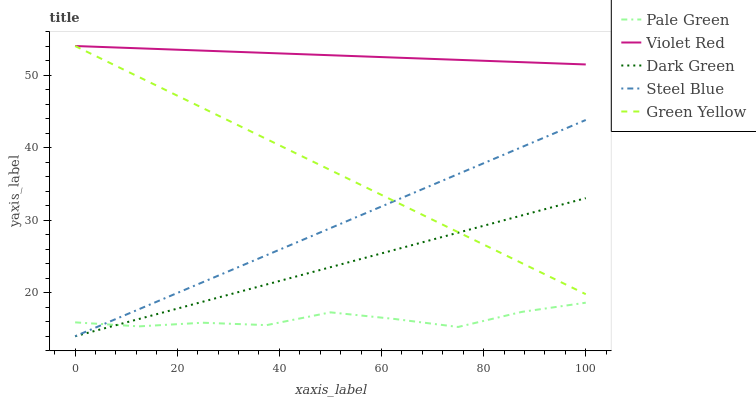Does Pale Green have the minimum area under the curve?
Answer yes or no. Yes. Does Violet Red have the maximum area under the curve?
Answer yes or no. Yes. Does Violet Red have the minimum area under the curve?
Answer yes or no. No. Does Pale Green have the maximum area under the curve?
Answer yes or no. No. Is Steel Blue the smoothest?
Answer yes or no. Yes. Is Pale Green the roughest?
Answer yes or no. Yes. Is Violet Red the smoothest?
Answer yes or no. No. Is Violet Red the roughest?
Answer yes or no. No. Does Steel Blue have the lowest value?
Answer yes or no. Yes. Does Pale Green have the lowest value?
Answer yes or no. No. Does Violet Red have the highest value?
Answer yes or no. Yes. Does Pale Green have the highest value?
Answer yes or no. No. Is Pale Green less than Violet Red?
Answer yes or no. Yes. Is Violet Red greater than Pale Green?
Answer yes or no. Yes. Does Steel Blue intersect Green Yellow?
Answer yes or no. Yes. Is Steel Blue less than Green Yellow?
Answer yes or no. No. Is Steel Blue greater than Green Yellow?
Answer yes or no. No. Does Pale Green intersect Violet Red?
Answer yes or no. No. 